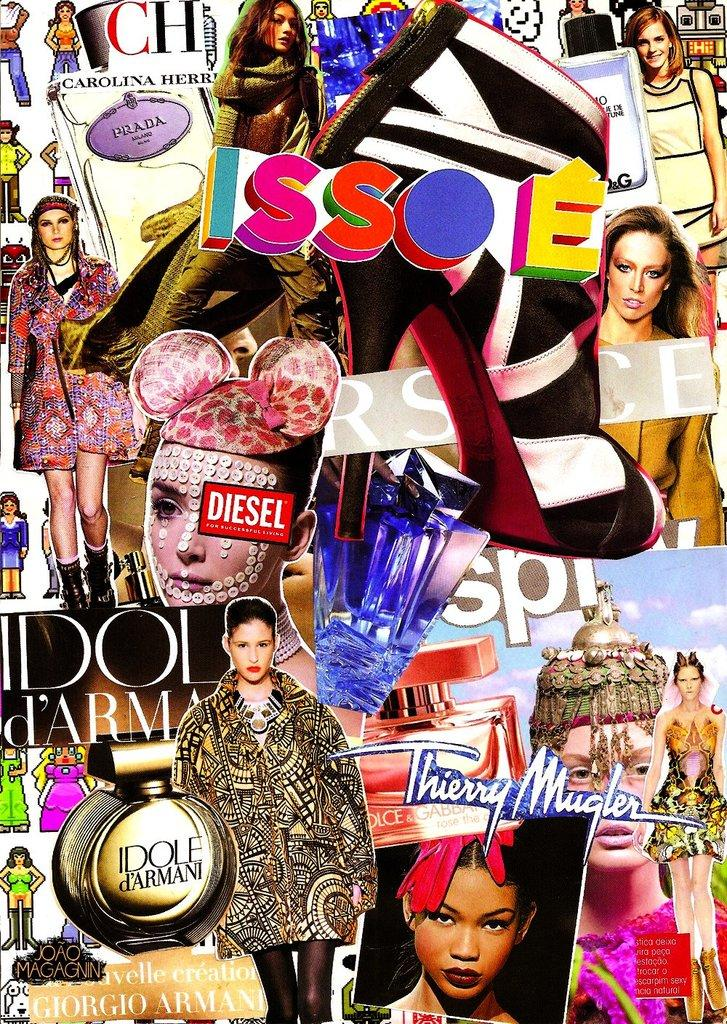<image>
Present a compact description of the photo's key features. A collage of items from magazines includes the brand name Diesel. 